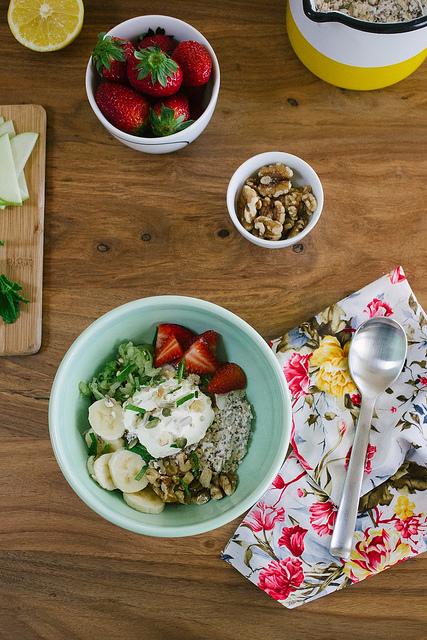How many strawberries are in the photo?
Quick response, please. 8. What is on the napkin?
Concise answer only. Flowers. Is the food healthy?
Concise answer only. Yes. 